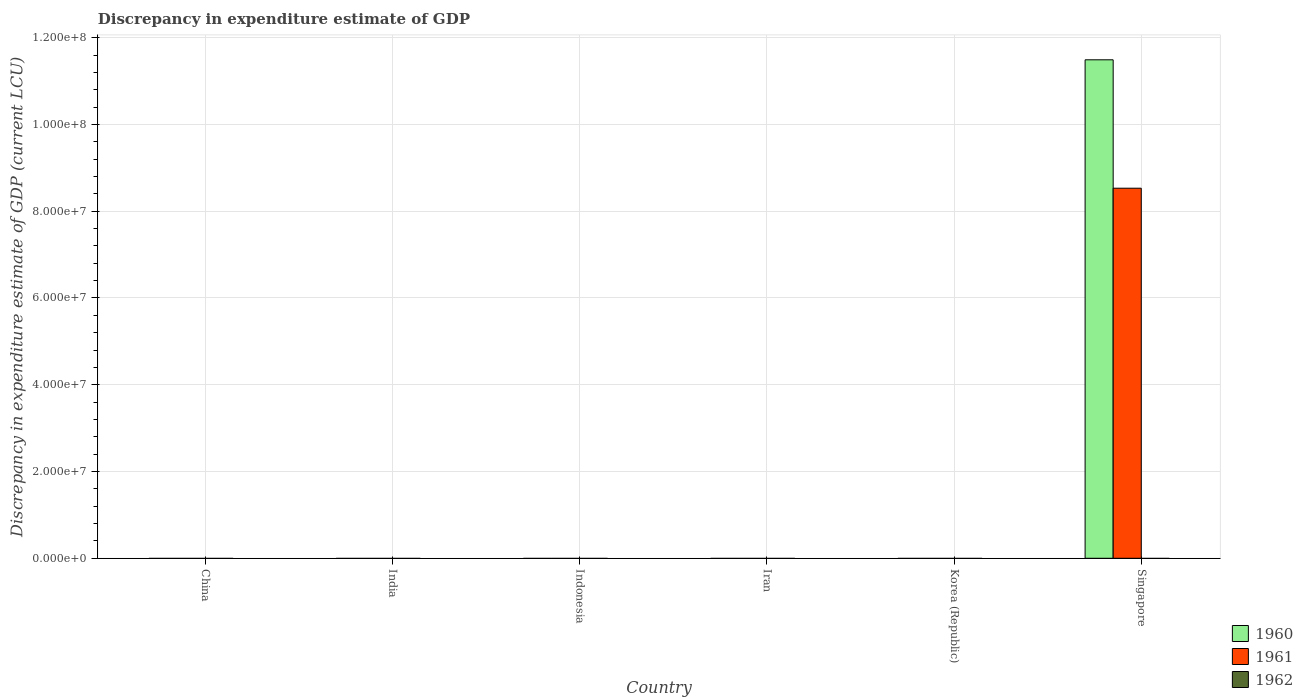In how many cases, is the number of bars for a given country not equal to the number of legend labels?
Make the answer very short. 6. What is the discrepancy in expenditure estimate of GDP in 1960 in Indonesia?
Provide a short and direct response. 0. Across all countries, what is the maximum discrepancy in expenditure estimate of GDP in 1960?
Keep it short and to the point. 1.15e+08. Across all countries, what is the minimum discrepancy in expenditure estimate of GDP in 1960?
Your answer should be compact. 0. In which country was the discrepancy in expenditure estimate of GDP in 1961 maximum?
Give a very brief answer. Singapore. What is the total discrepancy in expenditure estimate of GDP in 1962 in the graph?
Your response must be concise. 0. What is the average discrepancy in expenditure estimate of GDP in 1960 per country?
Offer a very short reply. 1.92e+07. What is the difference between the highest and the lowest discrepancy in expenditure estimate of GDP in 1961?
Make the answer very short. 8.53e+07. How many countries are there in the graph?
Provide a succinct answer. 6. Does the graph contain grids?
Your answer should be very brief. Yes. Where does the legend appear in the graph?
Provide a short and direct response. Bottom right. What is the title of the graph?
Make the answer very short. Discrepancy in expenditure estimate of GDP. Does "2001" appear as one of the legend labels in the graph?
Give a very brief answer. No. What is the label or title of the Y-axis?
Give a very brief answer. Discrepancy in expenditure estimate of GDP (current LCU). What is the Discrepancy in expenditure estimate of GDP (current LCU) of 1960 in China?
Offer a terse response. 0. What is the Discrepancy in expenditure estimate of GDP (current LCU) of 1961 in China?
Offer a very short reply. 0. What is the Discrepancy in expenditure estimate of GDP (current LCU) of 1962 in China?
Offer a terse response. 0. What is the Discrepancy in expenditure estimate of GDP (current LCU) of 1960 in India?
Keep it short and to the point. 0. What is the Discrepancy in expenditure estimate of GDP (current LCU) of 1961 in India?
Offer a very short reply. 0. What is the Discrepancy in expenditure estimate of GDP (current LCU) of 1962 in India?
Your answer should be very brief. 0. What is the Discrepancy in expenditure estimate of GDP (current LCU) of 1960 in Indonesia?
Make the answer very short. 0. What is the Discrepancy in expenditure estimate of GDP (current LCU) in 1961 in Indonesia?
Offer a very short reply. 0. What is the Discrepancy in expenditure estimate of GDP (current LCU) in 1962 in Indonesia?
Provide a succinct answer. 0. What is the Discrepancy in expenditure estimate of GDP (current LCU) in 1960 in Iran?
Your answer should be compact. 0. What is the Discrepancy in expenditure estimate of GDP (current LCU) of 1961 in Iran?
Your answer should be very brief. 0. What is the Discrepancy in expenditure estimate of GDP (current LCU) in 1962 in Iran?
Give a very brief answer. 0. What is the Discrepancy in expenditure estimate of GDP (current LCU) of 1960 in Korea (Republic)?
Provide a short and direct response. 0. What is the Discrepancy in expenditure estimate of GDP (current LCU) in 1962 in Korea (Republic)?
Offer a very short reply. 0. What is the Discrepancy in expenditure estimate of GDP (current LCU) in 1960 in Singapore?
Your answer should be compact. 1.15e+08. What is the Discrepancy in expenditure estimate of GDP (current LCU) of 1961 in Singapore?
Ensure brevity in your answer.  8.53e+07. What is the Discrepancy in expenditure estimate of GDP (current LCU) of 1962 in Singapore?
Your answer should be compact. 0. Across all countries, what is the maximum Discrepancy in expenditure estimate of GDP (current LCU) in 1960?
Your answer should be very brief. 1.15e+08. Across all countries, what is the maximum Discrepancy in expenditure estimate of GDP (current LCU) of 1961?
Your response must be concise. 8.53e+07. Across all countries, what is the minimum Discrepancy in expenditure estimate of GDP (current LCU) of 1960?
Offer a very short reply. 0. What is the total Discrepancy in expenditure estimate of GDP (current LCU) of 1960 in the graph?
Your answer should be very brief. 1.15e+08. What is the total Discrepancy in expenditure estimate of GDP (current LCU) of 1961 in the graph?
Provide a succinct answer. 8.53e+07. What is the total Discrepancy in expenditure estimate of GDP (current LCU) of 1962 in the graph?
Provide a short and direct response. 0. What is the average Discrepancy in expenditure estimate of GDP (current LCU) in 1960 per country?
Your answer should be compact. 1.92e+07. What is the average Discrepancy in expenditure estimate of GDP (current LCU) in 1961 per country?
Make the answer very short. 1.42e+07. What is the difference between the Discrepancy in expenditure estimate of GDP (current LCU) in 1960 and Discrepancy in expenditure estimate of GDP (current LCU) in 1961 in Singapore?
Your answer should be very brief. 2.96e+07. What is the difference between the highest and the lowest Discrepancy in expenditure estimate of GDP (current LCU) of 1960?
Ensure brevity in your answer.  1.15e+08. What is the difference between the highest and the lowest Discrepancy in expenditure estimate of GDP (current LCU) in 1961?
Give a very brief answer. 8.53e+07. 